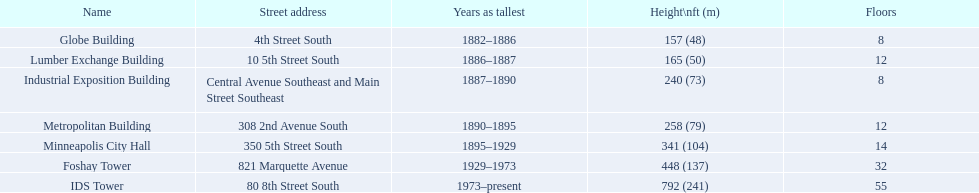What are the highest structures in minneapolis? Globe Building, Lumber Exchange Building, Industrial Exposition Building, Metropolitan Building, Minneapolis City Hall, Foshay Tower, IDS Tower. Which among them consist of 8 stories? Globe Building, Industrial Exposition Building. From those, which one is 240 ft in height? Industrial Exposition Building. 